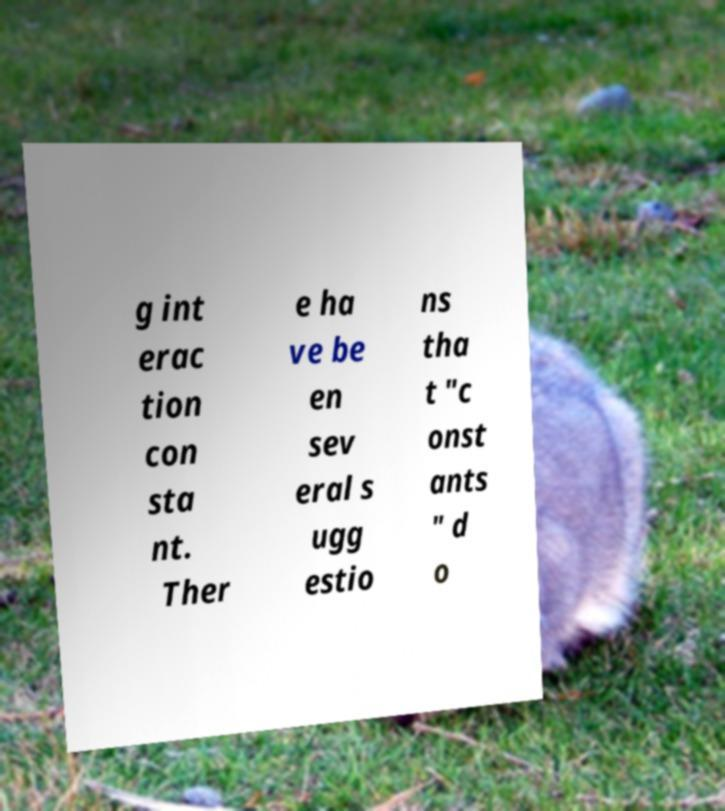Please read and relay the text visible in this image. What does it say? g int erac tion con sta nt. Ther e ha ve be en sev eral s ugg estio ns tha t "c onst ants " d o 